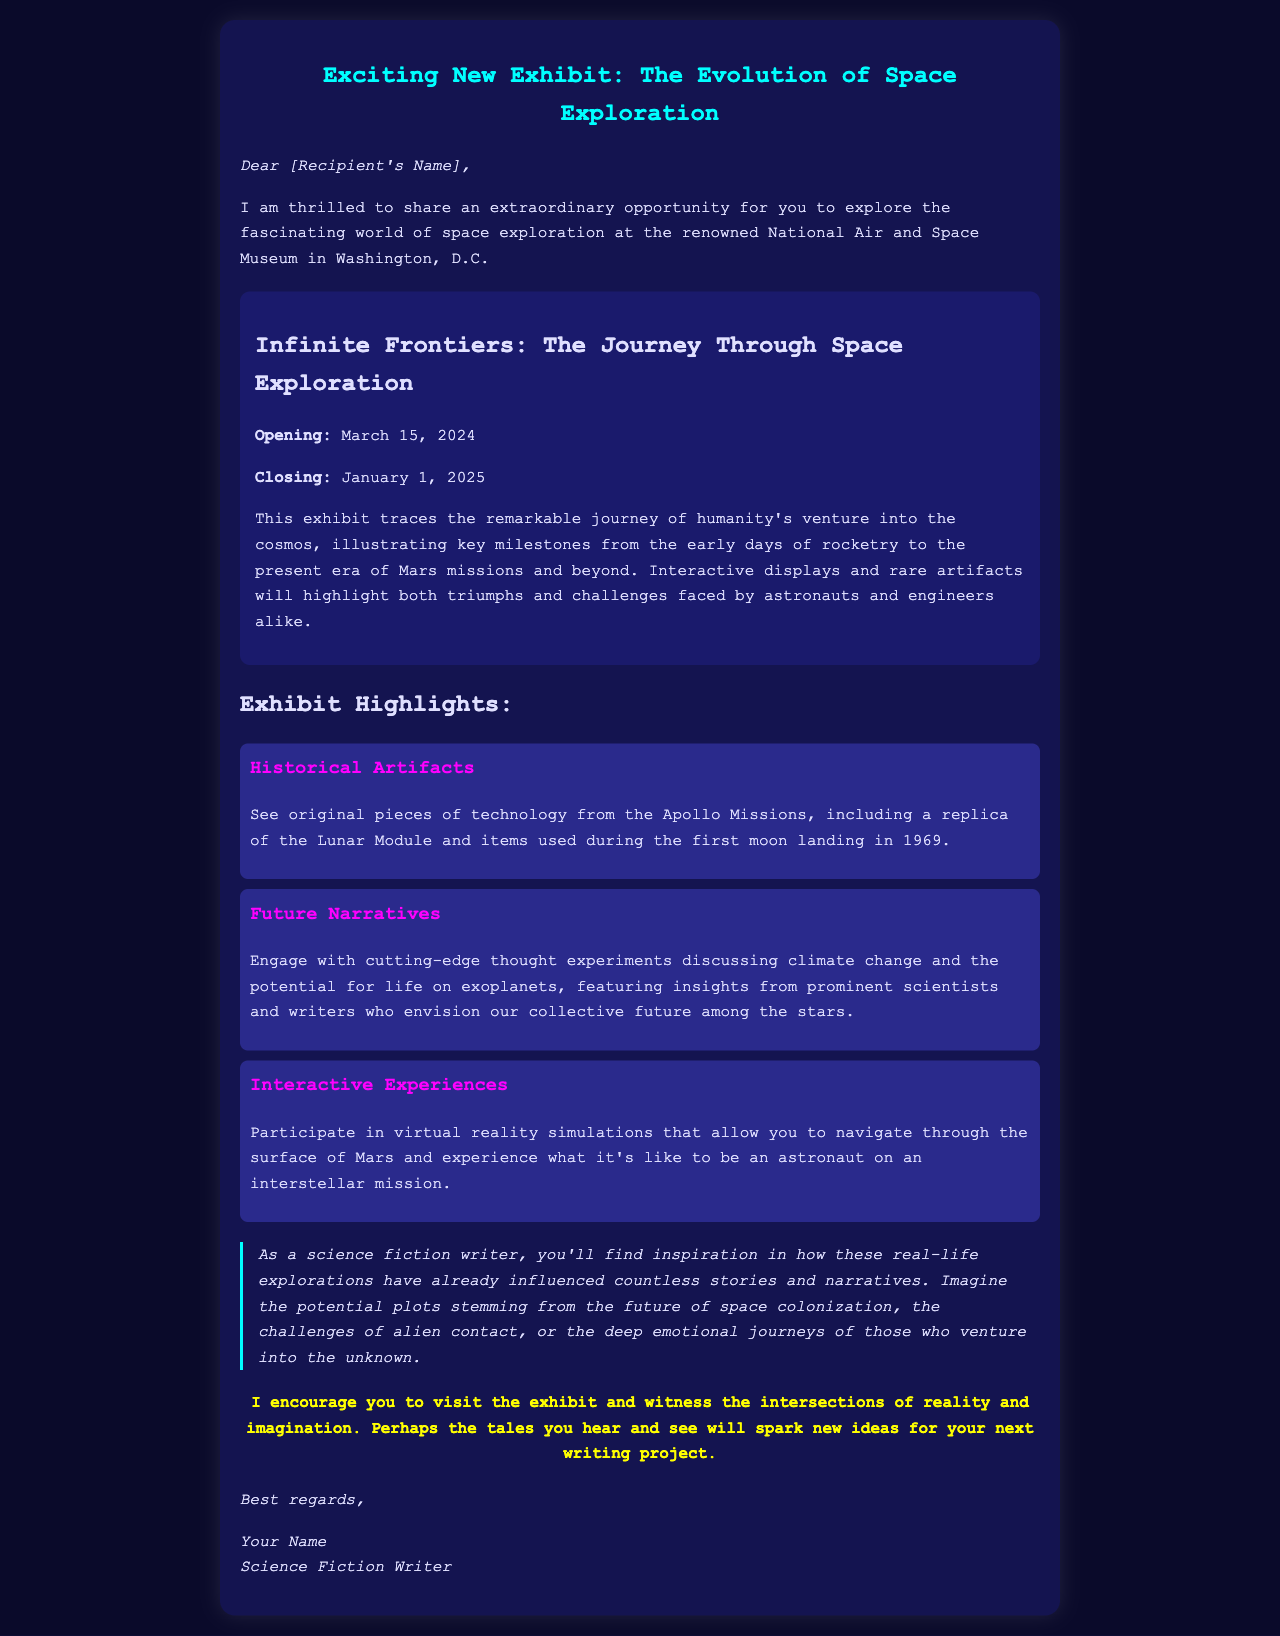What is the title of the exhibit? The title of the exhibit is mentioned prominently in the document.
Answer: Infinite Frontiers: The Journey Through Space Exploration When does the exhibit open? The opening date is clearly stated in the document.
Answer: March 15, 2024 What type of artifacts will be displayed? This refers to specific content related to the exhibit.
Answer: Historical Artifacts What can visitors engage with regarding future narratives? This details the focus of one of the highlight sections in the document.
Answer: Thought experiments What is one of the interactive experiences available? The document mentions specific interactive elements of the exhibit.
Answer: Virtual reality simulations What emotional themes are suggested for writing inspiration? This relates to the document’s encouragement for science fiction writers.
Answer: Deep emotional journeys Who is the intended audience for this exhibit? The document addresses a particular group in the closing remarks.
Answer: Science fiction writers What is the closing date of the exhibit? The closing date is noted in the exhibit details section.
Answer: January 1, 2025 